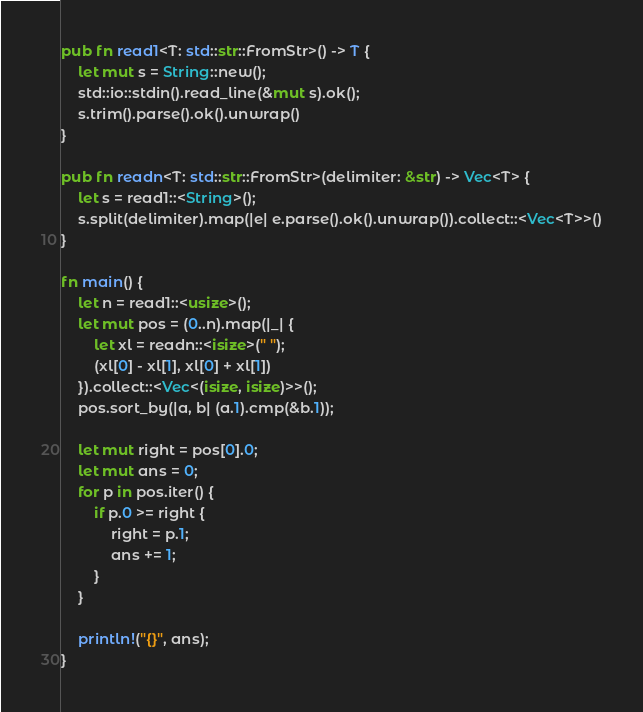Convert code to text. <code><loc_0><loc_0><loc_500><loc_500><_Rust_>pub fn read1<T: std::str::FromStr>() -> T {
    let mut s = String::new();
    std::io::stdin().read_line(&mut s).ok();
    s.trim().parse().ok().unwrap()
}

pub fn readn<T: std::str::FromStr>(delimiter: &str) -> Vec<T> {
    let s = read1::<String>();
    s.split(delimiter).map(|e| e.parse().ok().unwrap()).collect::<Vec<T>>()
}

fn main() {
    let n = read1::<usize>();
    let mut pos = (0..n).map(|_| {
        let xl = readn::<isize>(" ");
        (xl[0] - xl[1], xl[0] + xl[1])
    }).collect::<Vec<(isize, isize)>>();
    pos.sort_by(|a, b| (a.1).cmp(&b.1));

    let mut right = pos[0].0;
    let mut ans = 0;
    for p in pos.iter() {
        if p.0 >= right {
            right = p.1;
            ans += 1;
        }
    }

    println!("{}", ans);
}</code> 